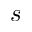<formula> <loc_0><loc_0><loc_500><loc_500>s</formula> 